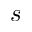<formula> <loc_0><loc_0><loc_500><loc_500>s</formula> 